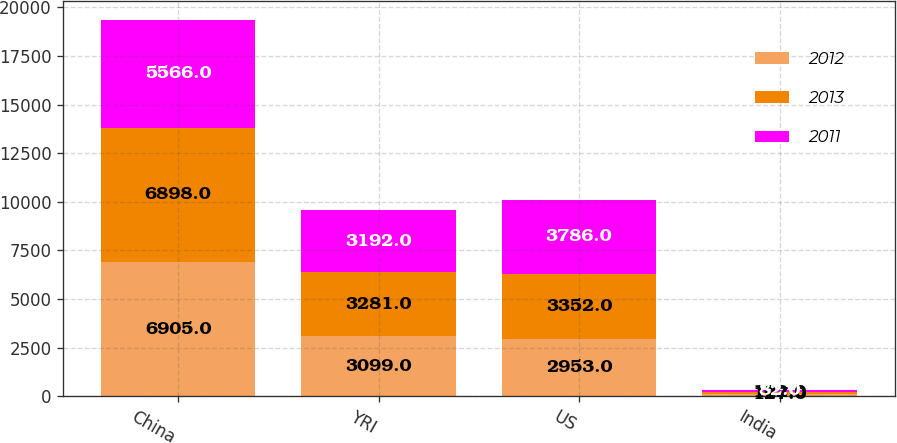Convert chart. <chart><loc_0><loc_0><loc_500><loc_500><stacked_bar_chart><ecel><fcel>China<fcel>YRI<fcel>US<fcel>India<nl><fcel>2012<fcel>6905<fcel>3099<fcel>2953<fcel>127<nl><fcel>2013<fcel>6898<fcel>3281<fcel>3352<fcel>102<nl><fcel>2011<fcel>5566<fcel>3192<fcel>3786<fcel>82<nl></chart> 